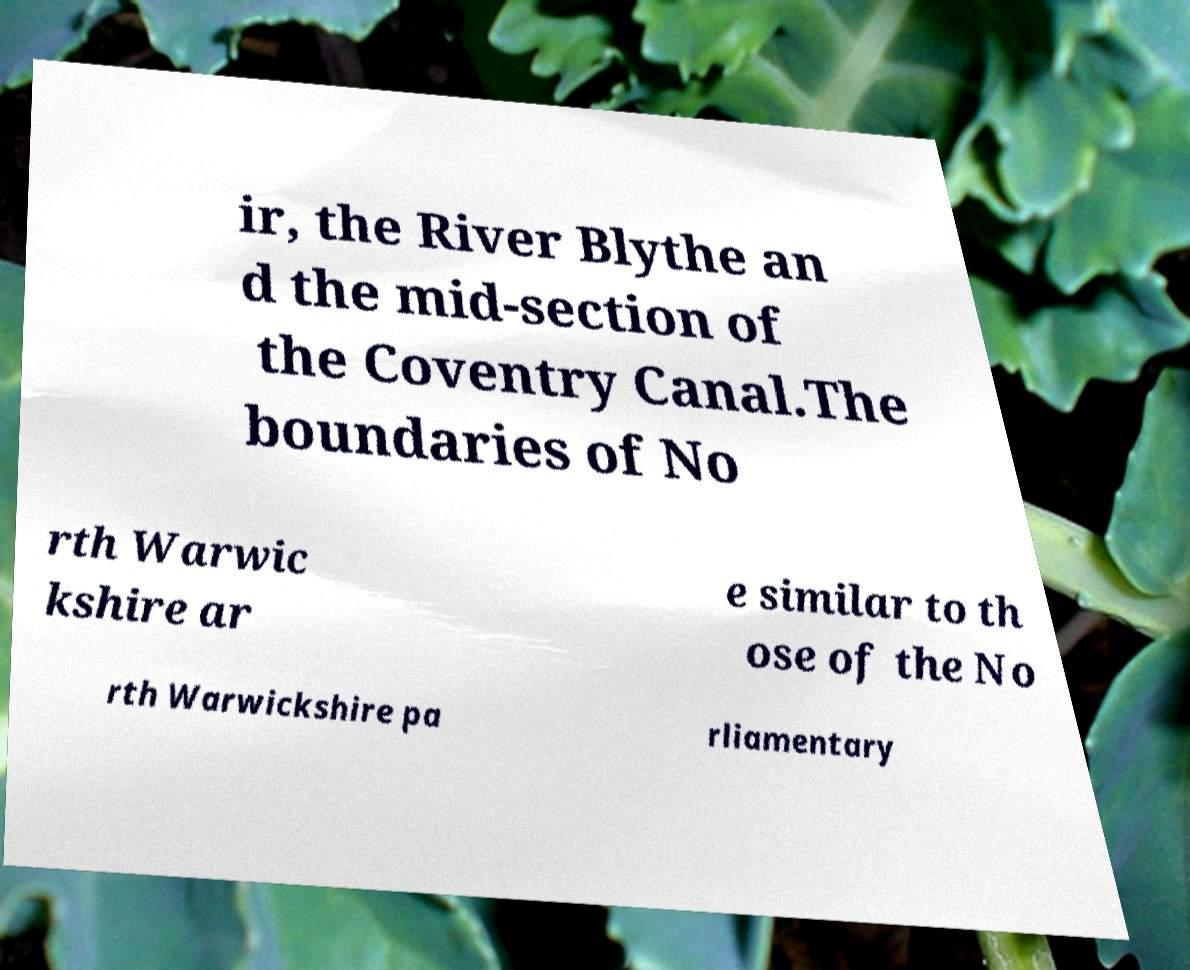For documentation purposes, I need the text within this image transcribed. Could you provide that? ir, the River Blythe an d the mid-section of the Coventry Canal.The boundaries of No rth Warwic kshire ar e similar to th ose of the No rth Warwickshire pa rliamentary 